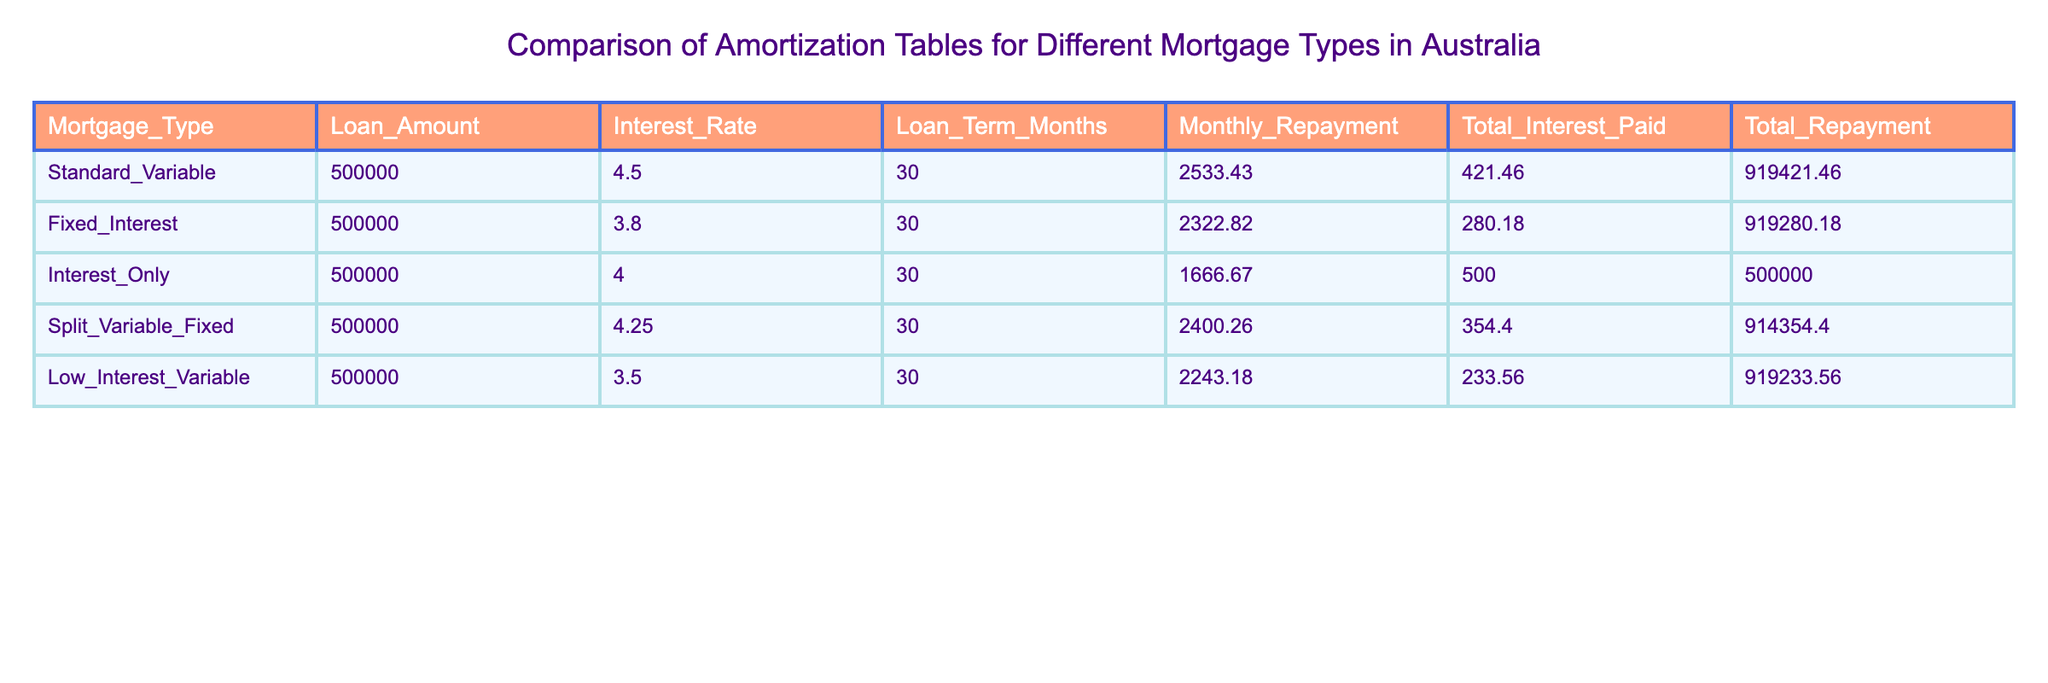What is the monthly repayment for the Fixed Interest mortgage? The table lists the Fixed Interest mortgage with a monthly repayment of 2322.82. This value is directly retrieved from the table.
Answer: 2322.82 Which mortgage type has the highest total repayment? To find the highest total repayment, we look at the Total Repayment column. The Standard Variable mortgage has a total repayment of 919421.46, which is the highest among all the types listed.
Answer: 919421.46 Is the total interest paid on the Interest Only mortgage higher than on the Low Interest Variable mortgage? The total interest paid for the Interest Only mortgage is 500.00, while for the Low Interest Variable mortgage it is 233.56. Since 500.00 is greater than 233.56, the Interest Only mortgage has a higher total interest paid.
Answer: Yes What is the difference in total interest paid between the Split Variable Fixed and the Fixed Interest mortgages? The total interest paid for the Split Variable Fixed mortgage is 354.40, and for the Fixed Interest mortgage, it is 280.18. To find the difference, we subtract: 354.40 - 280.18 = 74.22.
Answer: 74.22 Which mortgage type has the lowest interest rate and what is that rate? By examining the Interest Rate column, we see that the Low Interest Variable mortgage has the lowest rate of 3.50. This value is clearly stated in the table.
Answer: 3.50 How much more is the monthly repayment for the Standard Variable mortgage compared to the Interest Only mortgage? The monthly repayment for the Standard Variable mortgage is 2533.43 and for the Interest Only mortgage, it is 1666.67. The difference can be calculated as 2533.43 - 1666.67 = 866.76.
Answer: 866.76 Is the total repayment for the Low Interest Variable mortgage less than 900000? The total repayment for the Low Interest Variable mortgage is 919233.56. Since this value is greater than 900000, the statement is false.
Answer: No What is the average monthly repayment for all the mortgage types listed? The monthly repayments are 2533.43, 2322.82, 1666.67, 2400.26, and 2243.18. To find the average, we first add them together: 2533.43 + 2322.82 + 1666.67 + 2400.26 + 2243.18 = 11366.36, and then divide by 5 (the number of mortgage types) to get 11366.36/5 = 2273.27.
Answer: 2273.27 